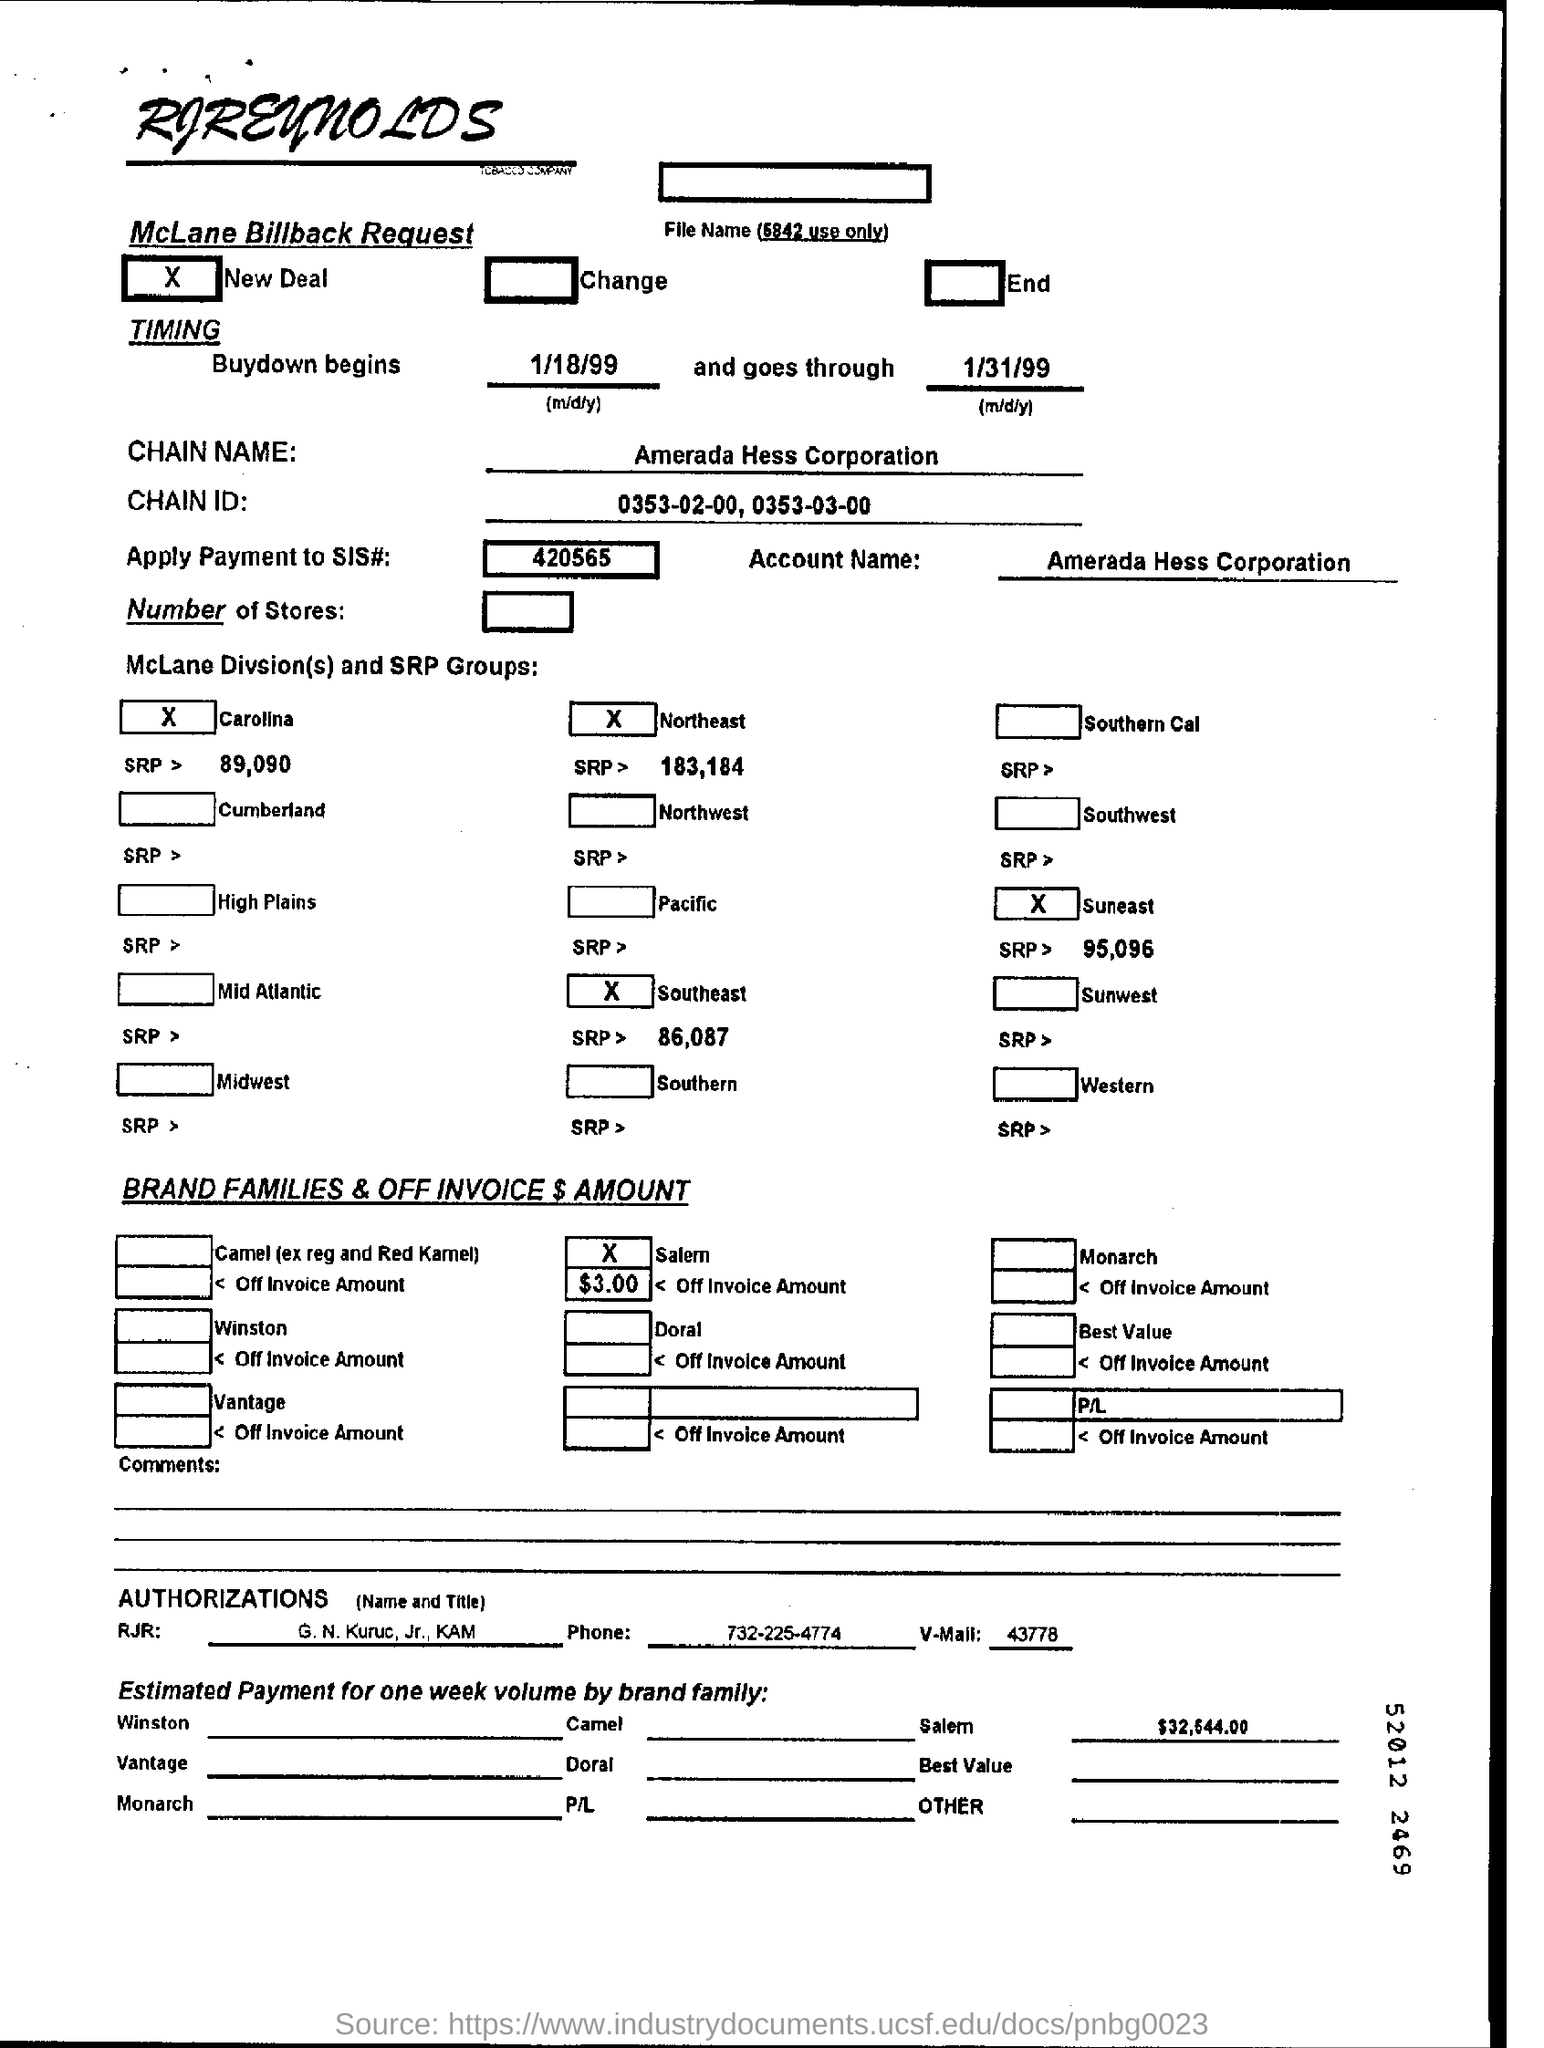What is the chain name?
Make the answer very short. Amerada Hess Corporation. Which company's name is at the top of the page?
Offer a terse response. RJReynolds. 